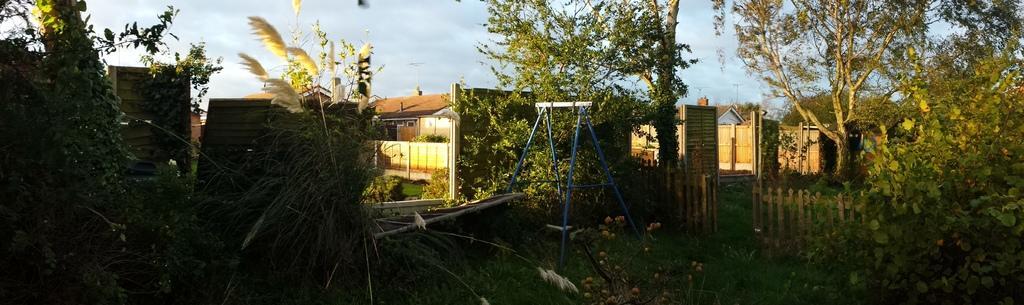Could you give a brief overview of what you see in this image? In this image, we can see sheds, trees, plants, a fence and there is a stand. In the background, we can see poles. At the top, there is sky. 